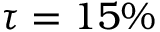Convert formula to latex. <formula><loc_0><loc_0><loc_500><loc_500>\tau = 1 5 \%</formula> 